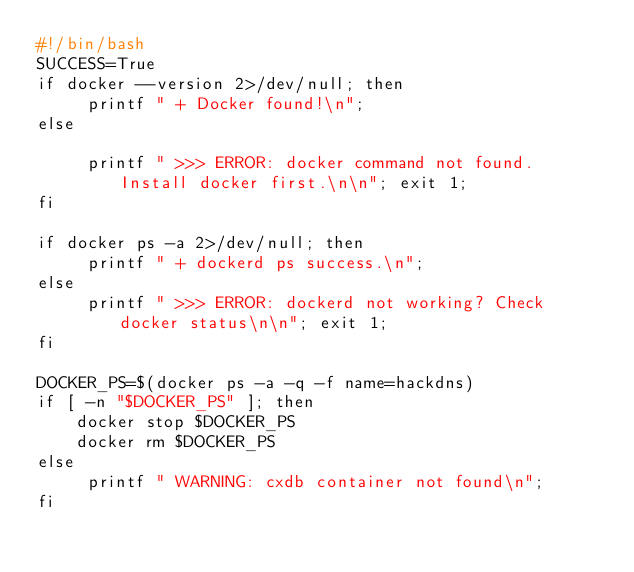<code> <loc_0><loc_0><loc_500><loc_500><_Bash_>#!/bin/bash
SUCCESS=True
if docker --version 2>/dev/null; then
     printf " + Docker found!\n";
else

     printf " >>> ERROR: docker command not found. Install docker first.\n\n"; exit 1;
fi

if docker ps -a 2>/dev/null; then
     printf " + dockerd ps success.\n";
else
     printf " >>> ERROR: dockerd not working? Check docker status\n\n"; exit 1;
fi

DOCKER_PS=$(docker ps -a -q -f name=hackdns)
if [ -n "$DOCKER_PS" ]; then
    docker stop $DOCKER_PS
    docker rm $DOCKER_PS
else 
     printf " WARNING: cxdb container not found\n";
fi</code> 